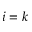Convert formula to latex. <formula><loc_0><loc_0><loc_500><loc_500>i = k</formula> 